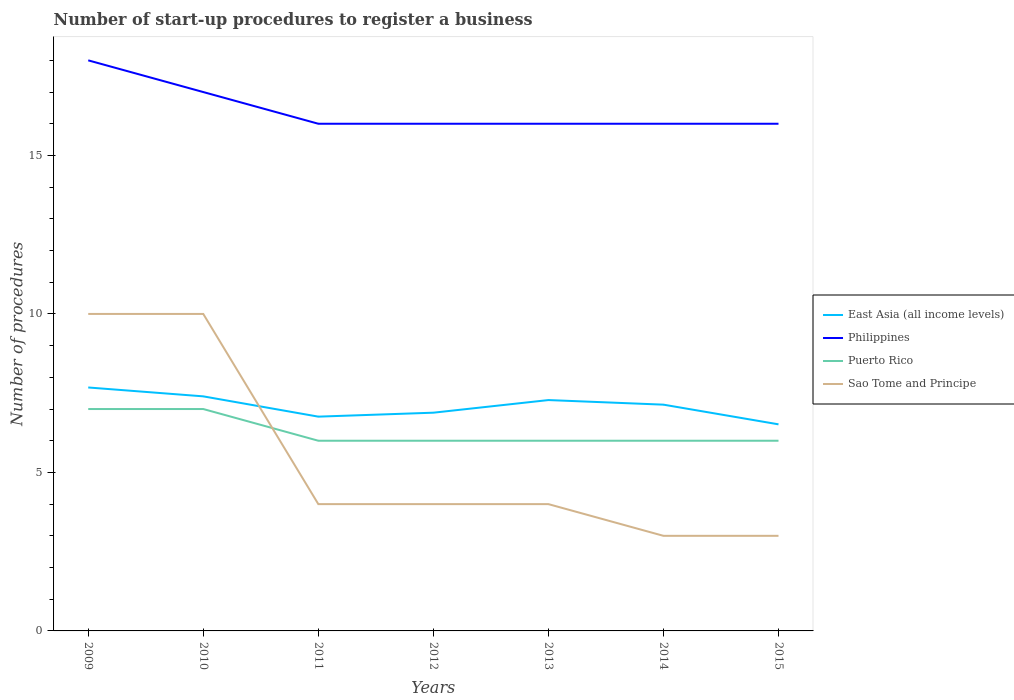Does the line corresponding to Sao Tome and Principe intersect with the line corresponding to East Asia (all income levels)?
Your answer should be very brief. Yes. Across all years, what is the maximum number of procedures required to register a business in Philippines?
Make the answer very short. 16. In which year was the number of procedures required to register a business in Philippines maximum?
Your answer should be compact. 2011. What is the total number of procedures required to register a business in East Asia (all income levels) in the graph?
Give a very brief answer. 0.14. What is the difference between the highest and the second highest number of procedures required to register a business in Philippines?
Keep it short and to the point. 2. What is the difference between the highest and the lowest number of procedures required to register a business in East Asia (all income levels)?
Offer a very short reply. 4. Is the number of procedures required to register a business in Puerto Rico strictly greater than the number of procedures required to register a business in Sao Tome and Principe over the years?
Offer a very short reply. No. What is the difference between two consecutive major ticks on the Y-axis?
Offer a very short reply. 5. Are the values on the major ticks of Y-axis written in scientific E-notation?
Ensure brevity in your answer.  No. Does the graph contain any zero values?
Your response must be concise. No. How many legend labels are there?
Provide a short and direct response. 4. How are the legend labels stacked?
Ensure brevity in your answer.  Vertical. What is the title of the graph?
Give a very brief answer. Number of start-up procedures to register a business. Does "Malaysia" appear as one of the legend labels in the graph?
Give a very brief answer. No. What is the label or title of the Y-axis?
Your response must be concise. Number of procedures. What is the Number of procedures in East Asia (all income levels) in 2009?
Make the answer very short. 7.68. What is the Number of procedures in Philippines in 2009?
Your answer should be very brief. 18. What is the Number of procedures of Sao Tome and Principe in 2009?
Your answer should be very brief. 10. What is the Number of procedures of Puerto Rico in 2010?
Keep it short and to the point. 7. What is the Number of procedures of East Asia (all income levels) in 2011?
Ensure brevity in your answer.  6.76. What is the Number of procedures of Sao Tome and Principe in 2011?
Your answer should be compact. 4. What is the Number of procedures of East Asia (all income levels) in 2012?
Your answer should be compact. 6.88. What is the Number of procedures in East Asia (all income levels) in 2013?
Your response must be concise. 7.28. What is the Number of procedures in Philippines in 2013?
Offer a very short reply. 16. What is the Number of procedures in Puerto Rico in 2013?
Give a very brief answer. 6. What is the Number of procedures of Sao Tome and Principe in 2013?
Give a very brief answer. 4. What is the Number of procedures in East Asia (all income levels) in 2014?
Your response must be concise. 7.14. What is the Number of procedures in Philippines in 2014?
Ensure brevity in your answer.  16. What is the Number of procedures of East Asia (all income levels) in 2015?
Give a very brief answer. 6.52. Across all years, what is the maximum Number of procedures of East Asia (all income levels)?
Offer a very short reply. 7.68. Across all years, what is the minimum Number of procedures in East Asia (all income levels)?
Ensure brevity in your answer.  6.52. Across all years, what is the minimum Number of procedures of Sao Tome and Principe?
Your answer should be very brief. 3. What is the total Number of procedures in East Asia (all income levels) in the graph?
Give a very brief answer. 49.66. What is the total Number of procedures in Philippines in the graph?
Offer a very short reply. 115. What is the total Number of procedures in Sao Tome and Principe in the graph?
Make the answer very short. 38. What is the difference between the Number of procedures in East Asia (all income levels) in 2009 and that in 2010?
Your response must be concise. 0.28. What is the difference between the Number of procedures of Philippines in 2009 and that in 2010?
Provide a succinct answer. 1. What is the difference between the Number of procedures of East Asia (all income levels) in 2009 and that in 2011?
Provide a succinct answer. 0.92. What is the difference between the Number of procedures in Philippines in 2009 and that in 2011?
Give a very brief answer. 2. What is the difference between the Number of procedures in Puerto Rico in 2009 and that in 2011?
Offer a terse response. 1. What is the difference between the Number of procedures in Sao Tome and Principe in 2009 and that in 2011?
Provide a succinct answer. 6. What is the difference between the Number of procedures of East Asia (all income levels) in 2009 and that in 2012?
Keep it short and to the point. 0.8. What is the difference between the Number of procedures in Sao Tome and Principe in 2009 and that in 2012?
Offer a very short reply. 6. What is the difference between the Number of procedures in East Asia (all income levels) in 2009 and that in 2013?
Provide a short and direct response. 0.4. What is the difference between the Number of procedures of Philippines in 2009 and that in 2013?
Offer a terse response. 2. What is the difference between the Number of procedures in Puerto Rico in 2009 and that in 2013?
Make the answer very short. 1. What is the difference between the Number of procedures of East Asia (all income levels) in 2009 and that in 2014?
Offer a very short reply. 0.54. What is the difference between the Number of procedures of Philippines in 2009 and that in 2014?
Offer a very short reply. 2. What is the difference between the Number of procedures of Puerto Rico in 2009 and that in 2014?
Keep it short and to the point. 1. What is the difference between the Number of procedures of East Asia (all income levels) in 2009 and that in 2015?
Your response must be concise. 1.16. What is the difference between the Number of procedures in Sao Tome and Principe in 2009 and that in 2015?
Offer a terse response. 7. What is the difference between the Number of procedures in East Asia (all income levels) in 2010 and that in 2011?
Give a very brief answer. 0.64. What is the difference between the Number of procedures of Philippines in 2010 and that in 2011?
Make the answer very short. 1. What is the difference between the Number of procedures in Puerto Rico in 2010 and that in 2011?
Ensure brevity in your answer.  1. What is the difference between the Number of procedures of Sao Tome and Principe in 2010 and that in 2011?
Give a very brief answer. 6. What is the difference between the Number of procedures in East Asia (all income levels) in 2010 and that in 2012?
Provide a succinct answer. 0.52. What is the difference between the Number of procedures in Puerto Rico in 2010 and that in 2012?
Make the answer very short. 1. What is the difference between the Number of procedures of East Asia (all income levels) in 2010 and that in 2013?
Offer a terse response. 0.12. What is the difference between the Number of procedures of Philippines in 2010 and that in 2013?
Provide a short and direct response. 1. What is the difference between the Number of procedures in Puerto Rico in 2010 and that in 2013?
Your answer should be compact. 1. What is the difference between the Number of procedures of East Asia (all income levels) in 2010 and that in 2014?
Keep it short and to the point. 0.26. What is the difference between the Number of procedures in Philippines in 2010 and that in 2014?
Offer a very short reply. 1. What is the difference between the Number of procedures of Sao Tome and Principe in 2010 and that in 2014?
Your response must be concise. 7. What is the difference between the Number of procedures in East Asia (all income levels) in 2010 and that in 2015?
Offer a very short reply. 0.88. What is the difference between the Number of procedures of Sao Tome and Principe in 2010 and that in 2015?
Your answer should be compact. 7. What is the difference between the Number of procedures in East Asia (all income levels) in 2011 and that in 2012?
Ensure brevity in your answer.  -0.12. What is the difference between the Number of procedures in Philippines in 2011 and that in 2012?
Your answer should be very brief. 0. What is the difference between the Number of procedures of Puerto Rico in 2011 and that in 2012?
Your answer should be compact. 0. What is the difference between the Number of procedures in East Asia (all income levels) in 2011 and that in 2013?
Provide a short and direct response. -0.52. What is the difference between the Number of procedures in Philippines in 2011 and that in 2013?
Ensure brevity in your answer.  0. What is the difference between the Number of procedures of Puerto Rico in 2011 and that in 2013?
Your answer should be very brief. 0. What is the difference between the Number of procedures of East Asia (all income levels) in 2011 and that in 2014?
Your response must be concise. -0.38. What is the difference between the Number of procedures in Philippines in 2011 and that in 2014?
Your response must be concise. 0. What is the difference between the Number of procedures of Puerto Rico in 2011 and that in 2014?
Provide a short and direct response. 0. What is the difference between the Number of procedures of East Asia (all income levels) in 2011 and that in 2015?
Provide a short and direct response. 0.24. What is the difference between the Number of procedures of Philippines in 2011 and that in 2015?
Your answer should be very brief. 0. What is the difference between the Number of procedures in Sao Tome and Principe in 2011 and that in 2015?
Provide a short and direct response. 1. What is the difference between the Number of procedures of East Asia (all income levels) in 2012 and that in 2013?
Your response must be concise. -0.4. What is the difference between the Number of procedures in Philippines in 2012 and that in 2013?
Your response must be concise. 0. What is the difference between the Number of procedures of Puerto Rico in 2012 and that in 2013?
Offer a very short reply. 0. What is the difference between the Number of procedures in East Asia (all income levels) in 2012 and that in 2014?
Keep it short and to the point. -0.25. What is the difference between the Number of procedures in Philippines in 2012 and that in 2014?
Provide a succinct answer. 0. What is the difference between the Number of procedures of Puerto Rico in 2012 and that in 2014?
Your response must be concise. 0. What is the difference between the Number of procedures in Sao Tome and Principe in 2012 and that in 2014?
Offer a terse response. 1. What is the difference between the Number of procedures of East Asia (all income levels) in 2012 and that in 2015?
Provide a short and direct response. 0.37. What is the difference between the Number of procedures of Sao Tome and Principe in 2012 and that in 2015?
Give a very brief answer. 1. What is the difference between the Number of procedures of East Asia (all income levels) in 2013 and that in 2014?
Offer a terse response. 0.14. What is the difference between the Number of procedures of Philippines in 2013 and that in 2014?
Make the answer very short. 0. What is the difference between the Number of procedures in Puerto Rico in 2013 and that in 2014?
Provide a succinct answer. 0. What is the difference between the Number of procedures of East Asia (all income levels) in 2013 and that in 2015?
Provide a short and direct response. 0.77. What is the difference between the Number of procedures in Puerto Rico in 2013 and that in 2015?
Provide a succinct answer. 0. What is the difference between the Number of procedures in Sao Tome and Principe in 2013 and that in 2015?
Keep it short and to the point. 1. What is the difference between the Number of procedures in East Asia (all income levels) in 2014 and that in 2015?
Make the answer very short. 0.62. What is the difference between the Number of procedures in Puerto Rico in 2014 and that in 2015?
Offer a very short reply. 0. What is the difference between the Number of procedures in East Asia (all income levels) in 2009 and the Number of procedures in Philippines in 2010?
Ensure brevity in your answer.  -9.32. What is the difference between the Number of procedures in East Asia (all income levels) in 2009 and the Number of procedures in Puerto Rico in 2010?
Keep it short and to the point. 0.68. What is the difference between the Number of procedures in East Asia (all income levels) in 2009 and the Number of procedures in Sao Tome and Principe in 2010?
Your answer should be compact. -2.32. What is the difference between the Number of procedures in Philippines in 2009 and the Number of procedures in Puerto Rico in 2010?
Your answer should be compact. 11. What is the difference between the Number of procedures of Philippines in 2009 and the Number of procedures of Sao Tome and Principe in 2010?
Give a very brief answer. 8. What is the difference between the Number of procedures of Puerto Rico in 2009 and the Number of procedures of Sao Tome and Principe in 2010?
Provide a short and direct response. -3. What is the difference between the Number of procedures in East Asia (all income levels) in 2009 and the Number of procedures in Philippines in 2011?
Ensure brevity in your answer.  -8.32. What is the difference between the Number of procedures of East Asia (all income levels) in 2009 and the Number of procedures of Puerto Rico in 2011?
Offer a terse response. 1.68. What is the difference between the Number of procedures in East Asia (all income levels) in 2009 and the Number of procedures in Sao Tome and Principe in 2011?
Your response must be concise. 3.68. What is the difference between the Number of procedures in Philippines in 2009 and the Number of procedures in Sao Tome and Principe in 2011?
Your answer should be very brief. 14. What is the difference between the Number of procedures in East Asia (all income levels) in 2009 and the Number of procedures in Philippines in 2012?
Offer a terse response. -8.32. What is the difference between the Number of procedures of East Asia (all income levels) in 2009 and the Number of procedures of Puerto Rico in 2012?
Offer a very short reply. 1.68. What is the difference between the Number of procedures of East Asia (all income levels) in 2009 and the Number of procedures of Sao Tome and Principe in 2012?
Ensure brevity in your answer.  3.68. What is the difference between the Number of procedures in Philippines in 2009 and the Number of procedures in Puerto Rico in 2012?
Give a very brief answer. 12. What is the difference between the Number of procedures in East Asia (all income levels) in 2009 and the Number of procedures in Philippines in 2013?
Provide a succinct answer. -8.32. What is the difference between the Number of procedures in East Asia (all income levels) in 2009 and the Number of procedures in Puerto Rico in 2013?
Provide a short and direct response. 1.68. What is the difference between the Number of procedures in East Asia (all income levels) in 2009 and the Number of procedures in Sao Tome and Principe in 2013?
Provide a short and direct response. 3.68. What is the difference between the Number of procedures of Philippines in 2009 and the Number of procedures of Puerto Rico in 2013?
Provide a succinct answer. 12. What is the difference between the Number of procedures of Philippines in 2009 and the Number of procedures of Sao Tome and Principe in 2013?
Your response must be concise. 14. What is the difference between the Number of procedures of Puerto Rico in 2009 and the Number of procedures of Sao Tome and Principe in 2013?
Your response must be concise. 3. What is the difference between the Number of procedures in East Asia (all income levels) in 2009 and the Number of procedures in Philippines in 2014?
Your answer should be compact. -8.32. What is the difference between the Number of procedures in East Asia (all income levels) in 2009 and the Number of procedures in Puerto Rico in 2014?
Offer a terse response. 1.68. What is the difference between the Number of procedures of East Asia (all income levels) in 2009 and the Number of procedures of Sao Tome and Principe in 2014?
Give a very brief answer. 4.68. What is the difference between the Number of procedures in Puerto Rico in 2009 and the Number of procedures in Sao Tome and Principe in 2014?
Give a very brief answer. 4. What is the difference between the Number of procedures of East Asia (all income levels) in 2009 and the Number of procedures of Philippines in 2015?
Offer a very short reply. -8.32. What is the difference between the Number of procedures in East Asia (all income levels) in 2009 and the Number of procedures in Puerto Rico in 2015?
Ensure brevity in your answer.  1.68. What is the difference between the Number of procedures of East Asia (all income levels) in 2009 and the Number of procedures of Sao Tome and Principe in 2015?
Give a very brief answer. 4.68. What is the difference between the Number of procedures in Philippines in 2009 and the Number of procedures in Sao Tome and Principe in 2015?
Provide a short and direct response. 15. What is the difference between the Number of procedures of Puerto Rico in 2010 and the Number of procedures of Sao Tome and Principe in 2011?
Provide a succinct answer. 3. What is the difference between the Number of procedures of Philippines in 2010 and the Number of procedures of Puerto Rico in 2012?
Ensure brevity in your answer.  11. What is the difference between the Number of procedures of Philippines in 2010 and the Number of procedures of Sao Tome and Principe in 2012?
Your response must be concise. 13. What is the difference between the Number of procedures of Puerto Rico in 2010 and the Number of procedures of Sao Tome and Principe in 2012?
Offer a terse response. 3. What is the difference between the Number of procedures of Puerto Rico in 2010 and the Number of procedures of Sao Tome and Principe in 2013?
Ensure brevity in your answer.  3. What is the difference between the Number of procedures of East Asia (all income levels) in 2010 and the Number of procedures of Philippines in 2014?
Your answer should be compact. -8.6. What is the difference between the Number of procedures in East Asia (all income levels) in 2010 and the Number of procedures in Puerto Rico in 2014?
Your answer should be compact. 1.4. What is the difference between the Number of procedures of East Asia (all income levels) in 2010 and the Number of procedures of Sao Tome and Principe in 2014?
Your response must be concise. 4.4. What is the difference between the Number of procedures in Philippines in 2010 and the Number of procedures in Sao Tome and Principe in 2014?
Make the answer very short. 14. What is the difference between the Number of procedures in Puerto Rico in 2010 and the Number of procedures in Sao Tome and Principe in 2014?
Offer a very short reply. 4. What is the difference between the Number of procedures in East Asia (all income levels) in 2010 and the Number of procedures in Philippines in 2015?
Your answer should be very brief. -8.6. What is the difference between the Number of procedures in Philippines in 2010 and the Number of procedures in Puerto Rico in 2015?
Keep it short and to the point. 11. What is the difference between the Number of procedures of Philippines in 2010 and the Number of procedures of Sao Tome and Principe in 2015?
Offer a terse response. 14. What is the difference between the Number of procedures in East Asia (all income levels) in 2011 and the Number of procedures in Philippines in 2012?
Give a very brief answer. -9.24. What is the difference between the Number of procedures of East Asia (all income levels) in 2011 and the Number of procedures of Puerto Rico in 2012?
Your answer should be very brief. 0.76. What is the difference between the Number of procedures of East Asia (all income levels) in 2011 and the Number of procedures of Sao Tome and Principe in 2012?
Offer a terse response. 2.76. What is the difference between the Number of procedures of Philippines in 2011 and the Number of procedures of Sao Tome and Principe in 2012?
Your answer should be very brief. 12. What is the difference between the Number of procedures of Puerto Rico in 2011 and the Number of procedures of Sao Tome and Principe in 2012?
Ensure brevity in your answer.  2. What is the difference between the Number of procedures in East Asia (all income levels) in 2011 and the Number of procedures in Philippines in 2013?
Offer a terse response. -9.24. What is the difference between the Number of procedures of East Asia (all income levels) in 2011 and the Number of procedures of Puerto Rico in 2013?
Keep it short and to the point. 0.76. What is the difference between the Number of procedures of East Asia (all income levels) in 2011 and the Number of procedures of Sao Tome and Principe in 2013?
Ensure brevity in your answer.  2.76. What is the difference between the Number of procedures in Puerto Rico in 2011 and the Number of procedures in Sao Tome and Principe in 2013?
Provide a short and direct response. 2. What is the difference between the Number of procedures of East Asia (all income levels) in 2011 and the Number of procedures of Philippines in 2014?
Offer a terse response. -9.24. What is the difference between the Number of procedures of East Asia (all income levels) in 2011 and the Number of procedures of Puerto Rico in 2014?
Provide a short and direct response. 0.76. What is the difference between the Number of procedures of East Asia (all income levels) in 2011 and the Number of procedures of Sao Tome and Principe in 2014?
Offer a very short reply. 3.76. What is the difference between the Number of procedures of Philippines in 2011 and the Number of procedures of Puerto Rico in 2014?
Your response must be concise. 10. What is the difference between the Number of procedures in East Asia (all income levels) in 2011 and the Number of procedures in Philippines in 2015?
Your response must be concise. -9.24. What is the difference between the Number of procedures of East Asia (all income levels) in 2011 and the Number of procedures of Puerto Rico in 2015?
Keep it short and to the point. 0.76. What is the difference between the Number of procedures of East Asia (all income levels) in 2011 and the Number of procedures of Sao Tome and Principe in 2015?
Give a very brief answer. 3.76. What is the difference between the Number of procedures of Philippines in 2011 and the Number of procedures of Sao Tome and Principe in 2015?
Give a very brief answer. 13. What is the difference between the Number of procedures of Puerto Rico in 2011 and the Number of procedures of Sao Tome and Principe in 2015?
Your answer should be compact. 3. What is the difference between the Number of procedures in East Asia (all income levels) in 2012 and the Number of procedures in Philippines in 2013?
Make the answer very short. -9.12. What is the difference between the Number of procedures of East Asia (all income levels) in 2012 and the Number of procedures of Puerto Rico in 2013?
Your response must be concise. 0.88. What is the difference between the Number of procedures of East Asia (all income levels) in 2012 and the Number of procedures of Sao Tome and Principe in 2013?
Offer a terse response. 2.88. What is the difference between the Number of procedures of Philippines in 2012 and the Number of procedures of Sao Tome and Principe in 2013?
Ensure brevity in your answer.  12. What is the difference between the Number of procedures of Puerto Rico in 2012 and the Number of procedures of Sao Tome and Principe in 2013?
Offer a very short reply. 2. What is the difference between the Number of procedures in East Asia (all income levels) in 2012 and the Number of procedures in Philippines in 2014?
Your answer should be compact. -9.12. What is the difference between the Number of procedures in East Asia (all income levels) in 2012 and the Number of procedures in Puerto Rico in 2014?
Your answer should be very brief. 0.88. What is the difference between the Number of procedures of East Asia (all income levels) in 2012 and the Number of procedures of Sao Tome and Principe in 2014?
Ensure brevity in your answer.  3.88. What is the difference between the Number of procedures in Philippines in 2012 and the Number of procedures in Puerto Rico in 2014?
Keep it short and to the point. 10. What is the difference between the Number of procedures in Puerto Rico in 2012 and the Number of procedures in Sao Tome and Principe in 2014?
Give a very brief answer. 3. What is the difference between the Number of procedures of East Asia (all income levels) in 2012 and the Number of procedures of Philippines in 2015?
Offer a very short reply. -9.12. What is the difference between the Number of procedures of East Asia (all income levels) in 2012 and the Number of procedures of Puerto Rico in 2015?
Provide a succinct answer. 0.88. What is the difference between the Number of procedures in East Asia (all income levels) in 2012 and the Number of procedures in Sao Tome and Principe in 2015?
Ensure brevity in your answer.  3.88. What is the difference between the Number of procedures of Philippines in 2012 and the Number of procedures of Puerto Rico in 2015?
Your answer should be very brief. 10. What is the difference between the Number of procedures in Puerto Rico in 2012 and the Number of procedures in Sao Tome and Principe in 2015?
Your answer should be very brief. 3. What is the difference between the Number of procedures in East Asia (all income levels) in 2013 and the Number of procedures in Philippines in 2014?
Your answer should be compact. -8.72. What is the difference between the Number of procedures of East Asia (all income levels) in 2013 and the Number of procedures of Puerto Rico in 2014?
Provide a succinct answer. 1.28. What is the difference between the Number of procedures in East Asia (all income levels) in 2013 and the Number of procedures in Sao Tome and Principe in 2014?
Make the answer very short. 4.28. What is the difference between the Number of procedures of Philippines in 2013 and the Number of procedures of Sao Tome and Principe in 2014?
Keep it short and to the point. 13. What is the difference between the Number of procedures of Puerto Rico in 2013 and the Number of procedures of Sao Tome and Principe in 2014?
Offer a very short reply. 3. What is the difference between the Number of procedures in East Asia (all income levels) in 2013 and the Number of procedures in Philippines in 2015?
Keep it short and to the point. -8.72. What is the difference between the Number of procedures in East Asia (all income levels) in 2013 and the Number of procedures in Puerto Rico in 2015?
Provide a succinct answer. 1.28. What is the difference between the Number of procedures of East Asia (all income levels) in 2013 and the Number of procedures of Sao Tome and Principe in 2015?
Provide a short and direct response. 4.28. What is the difference between the Number of procedures in Philippines in 2013 and the Number of procedures in Puerto Rico in 2015?
Your answer should be compact. 10. What is the difference between the Number of procedures in Philippines in 2013 and the Number of procedures in Sao Tome and Principe in 2015?
Offer a terse response. 13. What is the difference between the Number of procedures in East Asia (all income levels) in 2014 and the Number of procedures in Philippines in 2015?
Your response must be concise. -8.86. What is the difference between the Number of procedures of East Asia (all income levels) in 2014 and the Number of procedures of Puerto Rico in 2015?
Offer a terse response. 1.14. What is the difference between the Number of procedures of East Asia (all income levels) in 2014 and the Number of procedures of Sao Tome and Principe in 2015?
Your response must be concise. 4.14. What is the difference between the Number of procedures of Philippines in 2014 and the Number of procedures of Puerto Rico in 2015?
Give a very brief answer. 10. What is the difference between the Number of procedures in Puerto Rico in 2014 and the Number of procedures in Sao Tome and Principe in 2015?
Your answer should be very brief. 3. What is the average Number of procedures of East Asia (all income levels) per year?
Offer a very short reply. 7.09. What is the average Number of procedures in Philippines per year?
Your answer should be very brief. 16.43. What is the average Number of procedures in Puerto Rico per year?
Your response must be concise. 6.29. What is the average Number of procedures of Sao Tome and Principe per year?
Make the answer very short. 5.43. In the year 2009, what is the difference between the Number of procedures of East Asia (all income levels) and Number of procedures of Philippines?
Make the answer very short. -10.32. In the year 2009, what is the difference between the Number of procedures in East Asia (all income levels) and Number of procedures in Puerto Rico?
Your answer should be compact. 0.68. In the year 2009, what is the difference between the Number of procedures of East Asia (all income levels) and Number of procedures of Sao Tome and Principe?
Your answer should be very brief. -2.32. In the year 2009, what is the difference between the Number of procedures in Philippines and Number of procedures in Puerto Rico?
Your answer should be compact. 11. In the year 2009, what is the difference between the Number of procedures in Puerto Rico and Number of procedures in Sao Tome and Principe?
Provide a succinct answer. -3. In the year 2011, what is the difference between the Number of procedures of East Asia (all income levels) and Number of procedures of Philippines?
Make the answer very short. -9.24. In the year 2011, what is the difference between the Number of procedures of East Asia (all income levels) and Number of procedures of Puerto Rico?
Your answer should be compact. 0.76. In the year 2011, what is the difference between the Number of procedures of East Asia (all income levels) and Number of procedures of Sao Tome and Principe?
Your answer should be compact. 2.76. In the year 2011, what is the difference between the Number of procedures in Philippines and Number of procedures in Sao Tome and Principe?
Make the answer very short. 12. In the year 2012, what is the difference between the Number of procedures of East Asia (all income levels) and Number of procedures of Philippines?
Your response must be concise. -9.12. In the year 2012, what is the difference between the Number of procedures of East Asia (all income levels) and Number of procedures of Puerto Rico?
Provide a short and direct response. 0.88. In the year 2012, what is the difference between the Number of procedures in East Asia (all income levels) and Number of procedures in Sao Tome and Principe?
Your answer should be very brief. 2.88. In the year 2012, what is the difference between the Number of procedures in Philippines and Number of procedures in Puerto Rico?
Your response must be concise. 10. In the year 2012, what is the difference between the Number of procedures in Philippines and Number of procedures in Sao Tome and Principe?
Provide a succinct answer. 12. In the year 2013, what is the difference between the Number of procedures in East Asia (all income levels) and Number of procedures in Philippines?
Offer a very short reply. -8.72. In the year 2013, what is the difference between the Number of procedures in East Asia (all income levels) and Number of procedures in Puerto Rico?
Your answer should be compact. 1.28. In the year 2013, what is the difference between the Number of procedures in East Asia (all income levels) and Number of procedures in Sao Tome and Principe?
Offer a terse response. 3.28. In the year 2013, what is the difference between the Number of procedures in Philippines and Number of procedures in Sao Tome and Principe?
Your answer should be very brief. 12. In the year 2014, what is the difference between the Number of procedures of East Asia (all income levels) and Number of procedures of Philippines?
Your response must be concise. -8.86. In the year 2014, what is the difference between the Number of procedures of East Asia (all income levels) and Number of procedures of Puerto Rico?
Ensure brevity in your answer.  1.14. In the year 2014, what is the difference between the Number of procedures in East Asia (all income levels) and Number of procedures in Sao Tome and Principe?
Make the answer very short. 4.14. In the year 2014, what is the difference between the Number of procedures in Philippines and Number of procedures in Sao Tome and Principe?
Your answer should be very brief. 13. In the year 2015, what is the difference between the Number of procedures in East Asia (all income levels) and Number of procedures in Philippines?
Your response must be concise. -9.48. In the year 2015, what is the difference between the Number of procedures in East Asia (all income levels) and Number of procedures in Puerto Rico?
Give a very brief answer. 0.52. In the year 2015, what is the difference between the Number of procedures in East Asia (all income levels) and Number of procedures in Sao Tome and Principe?
Your answer should be compact. 3.52. In the year 2015, what is the difference between the Number of procedures of Philippines and Number of procedures of Puerto Rico?
Keep it short and to the point. 10. In the year 2015, what is the difference between the Number of procedures in Puerto Rico and Number of procedures in Sao Tome and Principe?
Make the answer very short. 3. What is the ratio of the Number of procedures of East Asia (all income levels) in 2009 to that in 2010?
Keep it short and to the point. 1.04. What is the ratio of the Number of procedures of Philippines in 2009 to that in 2010?
Your answer should be very brief. 1.06. What is the ratio of the Number of procedures in East Asia (all income levels) in 2009 to that in 2011?
Ensure brevity in your answer.  1.14. What is the ratio of the Number of procedures of Puerto Rico in 2009 to that in 2011?
Offer a terse response. 1.17. What is the ratio of the Number of procedures in Sao Tome and Principe in 2009 to that in 2011?
Keep it short and to the point. 2.5. What is the ratio of the Number of procedures in East Asia (all income levels) in 2009 to that in 2012?
Make the answer very short. 1.12. What is the ratio of the Number of procedures in Philippines in 2009 to that in 2012?
Your answer should be very brief. 1.12. What is the ratio of the Number of procedures of Puerto Rico in 2009 to that in 2012?
Offer a very short reply. 1.17. What is the ratio of the Number of procedures of Sao Tome and Principe in 2009 to that in 2012?
Give a very brief answer. 2.5. What is the ratio of the Number of procedures of East Asia (all income levels) in 2009 to that in 2013?
Provide a succinct answer. 1.05. What is the ratio of the Number of procedures of Philippines in 2009 to that in 2013?
Give a very brief answer. 1.12. What is the ratio of the Number of procedures in East Asia (all income levels) in 2009 to that in 2014?
Provide a succinct answer. 1.08. What is the ratio of the Number of procedures of East Asia (all income levels) in 2009 to that in 2015?
Give a very brief answer. 1.18. What is the ratio of the Number of procedures of Sao Tome and Principe in 2009 to that in 2015?
Keep it short and to the point. 3.33. What is the ratio of the Number of procedures in East Asia (all income levels) in 2010 to that in 2011?
Provide a short and direct response. 1.09. What is the ratio of the Number of procedures of Sao Tome and Principe in 2010 to that in 2011?
Provide a short and direct response. 2.5. What is the ratio of the Number of procedures of East Asia (all income levels) in 2010 to that in 2012?
Keep it short and to the point. 1.07. What is the ratio of the Number of procedures of Philippines in 2010 to that in 2012?
Offer a very short reply. 1.06. What is the ratio of the Number of procedures in East Asia (all income levels) in 2010 to that in 2013?
Give a very brief answer. 1.02. What is the ratio of the Number of procedures in Puerto Rico in 2010 to that in 2013?
Ensure brevity in your answer.  1.17. What is the ratio of the Number of procedures of Sao Tome and Principe in 2010 to that in 2013?
Offer a very short reply. 2.5. What is the ratio of the Number of procedures in East Asia (all income levels) in 2010 to that in 2014?
Your response must be concise. 1.04. What is the ratio of the Number of procedures in Philippines in 2010 to that in 2014?
Provide a short and direct response. 1.06. What is the ratio of the Number of procedures in Puerto Rico in 2010 to that in 2014?
Ensure brevity in your answer.  1.17. What is the ratio of the Number of procedures in East Asia (all income levels) in 2010 to that in 2015?
Give a very brief answer. 1.14. What is the ratio of the Number of procedures of Sao Tome and Principe in 2010 to that in 2015?
Provide a succinct answer. 3.33. What is the ratio of the Number of procedures in East Asia (all income levels) in 2011 to that in 2012?
Provide a short and direct response. 0.98. What is the ratio of the Number of procedures of Puerto Rico in 2011 to that in 2012?
Ensure brevity in your answer.  1. What is the ratio of the Number of procedures of East Asia (all income levels) in 2011 to that in 2013?
Offer a very short reply. 0.93. What is the ratio of the Number of procedures of Philippines in 2011 to that in 2013?
Your answer should be compact. 1. What is the ratio of the Number of procedures of East Asia (all income levels) in 2011 to that in 2014?
Your answer should be compact. 0.95. What is the ratio of the Number of procedures in Puerto Rico in 2011 to that in 2014?
Offer a terse response. 1. What is the ratio of the Number of procedures in Sao Tome and Principe in 2011 to that in 2014?
Give a very brief answer. 1.33. What is the ratio of the Number of procedures of East Asia (all income levels) in 2011 to that in 2015?
Keep it short and to the point. 1.04. What is the ratio of the Number of procedures in Philippines in 2011 to that in 2015?
Give a very brief answer. 1. What is the ratio of the Number of procedures in Puerto Rico in 2011 to that in 2015?
Your answer should be compact. 1. What is the ratio of the Number of procedures in Sao Tome and Principe in 2011 to that in 2015?
Offer a terse response. 1.33. What is the ratio of the Number of procedures in East Asia (all income levels) in 2012 to that in 2013?
Provide a succinct answer. 0.95. What is the ratio of the Number of procedures of Philippines in 2012 to that in 2013?
Keep it short and to the point. 1. What is the ratio of the Number of procedures in Sao Tome and Principe in 2012 to that in 2013?
Your answer should be compact. 1. What is the ratio of the Number of procedures of East Asia (all income levels) in 2012 to that in 2014?
Provide a succinct answer. 0.96. What is the ratio of the Number of procedures of East Asia (all income levels) in 2012 to that in 2015?
Give a very brief answer. 1.06. What is the ratio of the Number of procedures of East Asia (all income levels) in 2013 to that in 2014?
Offer a very short reply. 1.02. What is the ratio of the Number of procedures in Philippines in 2013 to that in 2014?
Your answer should be compact. 1. What is the ratio of the Number of procedures in East Asia (all income levels) in 2013 to that in 2015?
Your response must be concise. 1.12. What is the ratio of the Number of procedures of Puerto Rico in 2013 to that in 2015?
Ensure brevity in your answer.  1. What is the ratio of the Number of procedures in Sao Tome and Principe in 2013 to that in 2015?
Offer a very short reply. 1.33. What is the ratio of the Number of procedures of East Asia (all income levels) in 2014 to that in 2015?
Keep it short and to the point. 1.1. What is the ratio of the Number of procedures in Puerto Rico in 2014 to that in 2015?
Offer a terse response. 1. What is the ratio of the Number of procedures in Sao Tome and Principe in 2014 to that in 2015?
Keep it short and to the point. 1. What is the difference between the highest and the second highest Number of procedures of East Asia (all income levels)?
Your response must be concise. 0.28. What is the difference between the highest and the second highest Number of procedures of Philippines?
Give a very brief answer. 1. What is the difference between the highest and the lowest Number of procedures of East Asia (all income levels)?
Give a very brief answer. 1.16. 